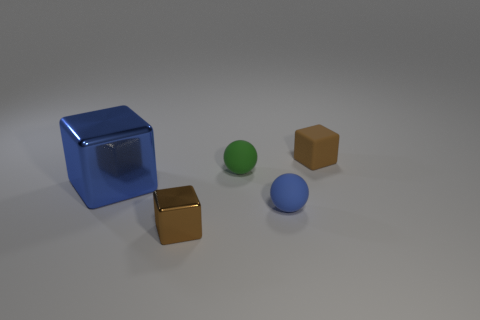Add 3 blue rubber spheres. How many objects exist? 8 Subtract all small brown rubber cubes. How many cubes are left? 2 Subtract all yellow cylinders. How many brown blocks are left? 2 Subtract all spheres. How many objects are left? 3 Subtract all brown cubes. How many cubes are left? 1 Add 1 tiny shiny things. How many tiny shiny things are left? 2 Add 1 large blue blocks. How many large blue blocks exist? 2 Subtract 0 cyan blocks. How many objects are left? 5 Subtract all green cubes. Subtract all gray balls. How many cubes are left? 3 Subtract all tiny metal cubes. Subtract all tiny brown blocks. How many objects are left? 2 